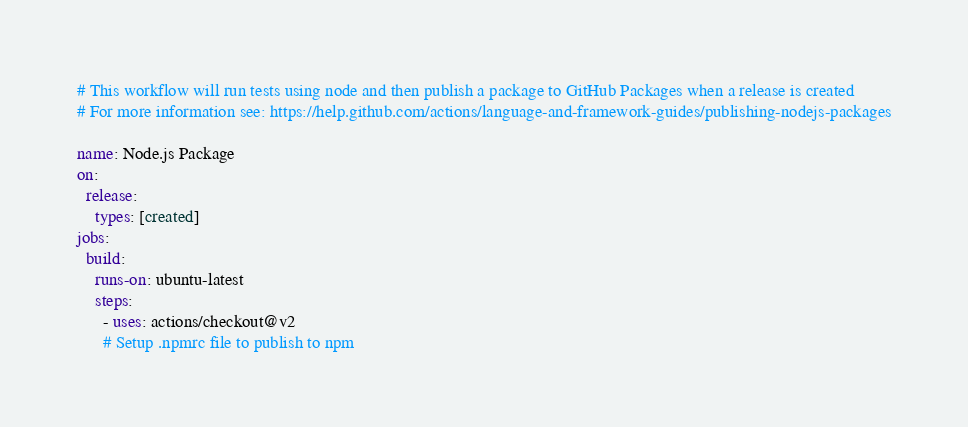Convert code to text. <code><loc_0><loc_0><loc_500><loc_500><_YAML_># This workflow will run tests using node and then publish a package to GitHub Packages when a release is created
# For more information see: https://help.github.com/actions/language-and-framework-guides/publishing-nodejs-packages

name: Node.js Package
on:
  release:
    types: [created]
jobs:
  build:
    runs-on: ubuntu-latest
    steps:
      - uses: actions/checkout@v2
      # Setup .npmrc file to publish to npm</code> 